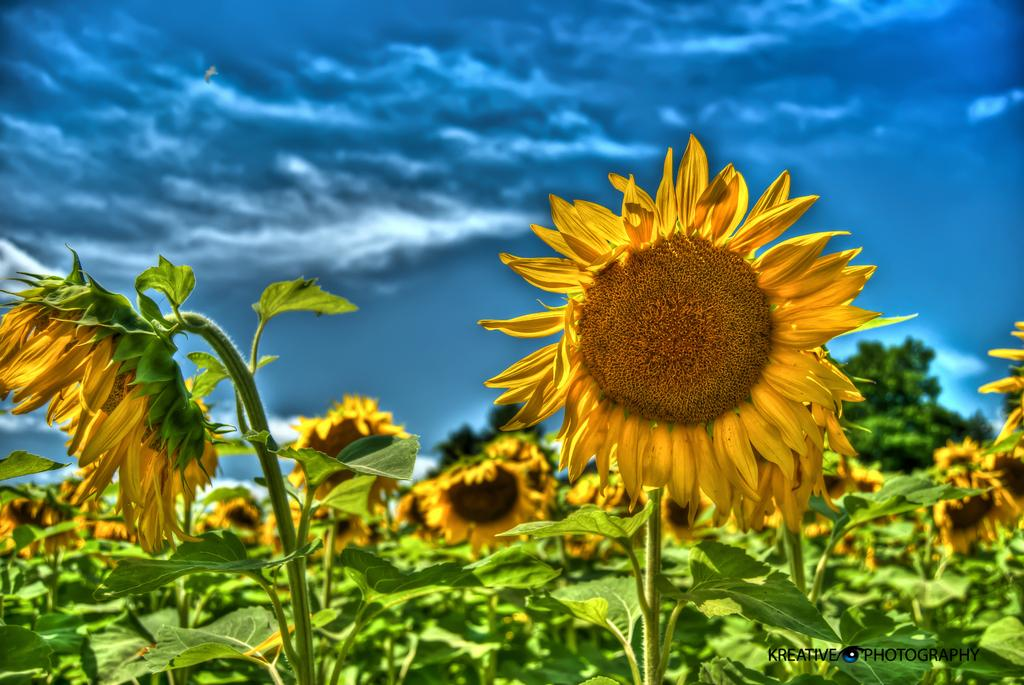What type of living organisms can be seen in the image? Plants can be seen in the image. What is visible at the top of the image? The sky is visible at the top of the image. How many mice are visible in the image? There are no mice present in the image. What type of thread is being used to hold the plants together in the image? There is no thread visible in the image, and the plants are not being held together. 